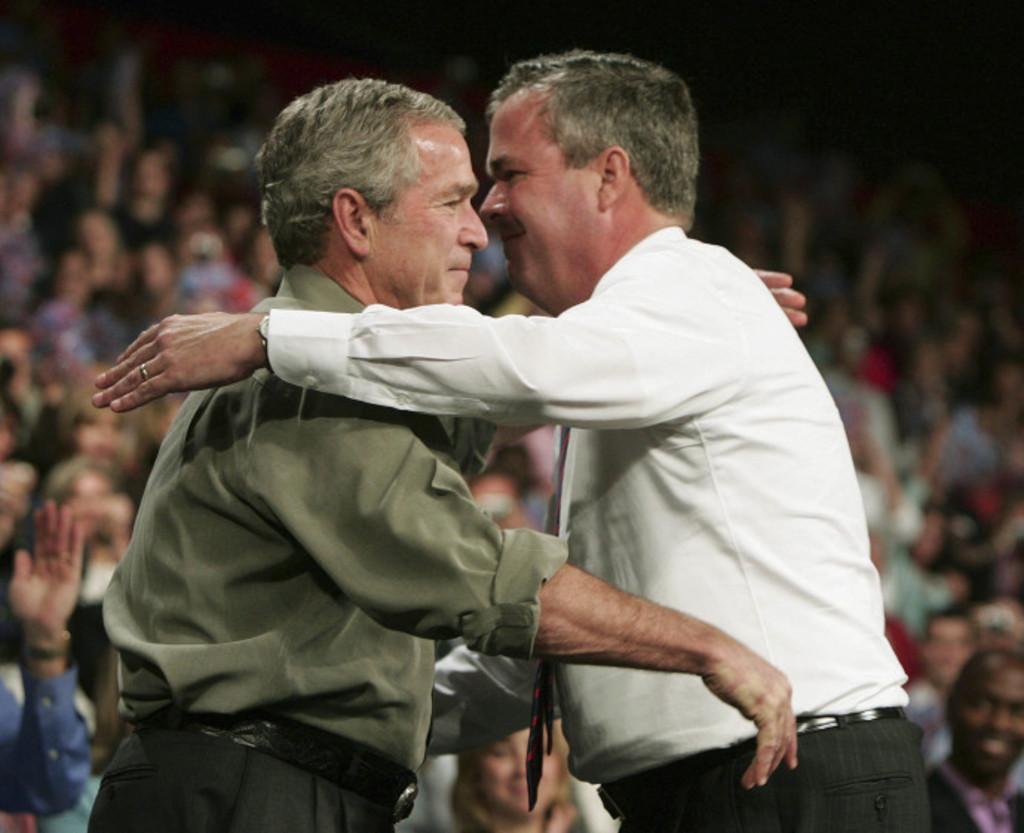In one or two sentences, can you explain what this image depicts? In the picture we can see two men are going to hug each other, one man is wearing a green shirt and one is wearing a white shirt and in the background we can see people sitting on the chairs and some people are clapping hands. 